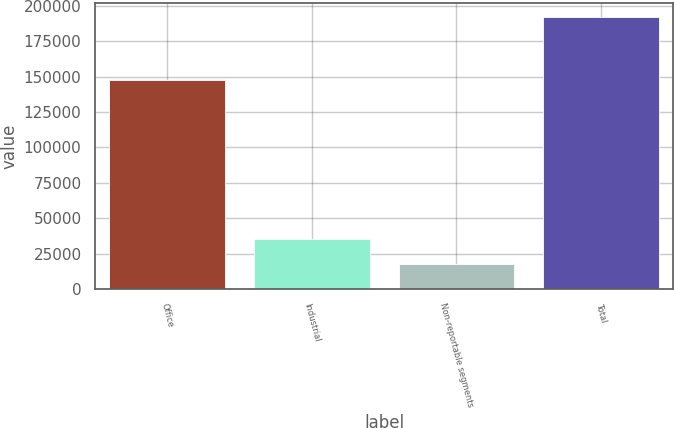<chart> <loc_0><loc_0><loc_500><loc_500><bar_chart><fcel>Office<fcel>Industrial<fcel>Non-reportable segments<fcel>Total<nl><fcel>147774<fcel>34959<fcel>17480<fcel>192270<nl></chart> 